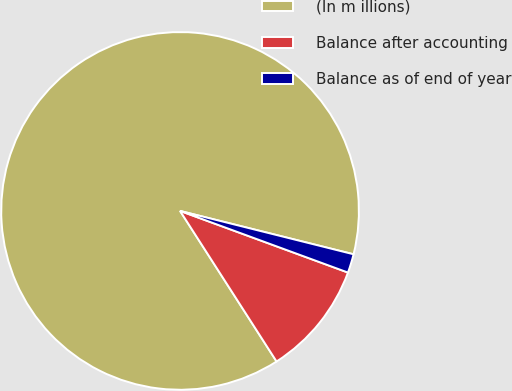Convert chart. <chart><loc_0><loc_0><loc_500><loc_500><pie_chart><fcel>(In m illions)<fcel>Balance after accounting<fcel>Balance as of end of year<nl><fcel>87.97%<fcel>10.33%<fcel>1.7%<nl></chart> 